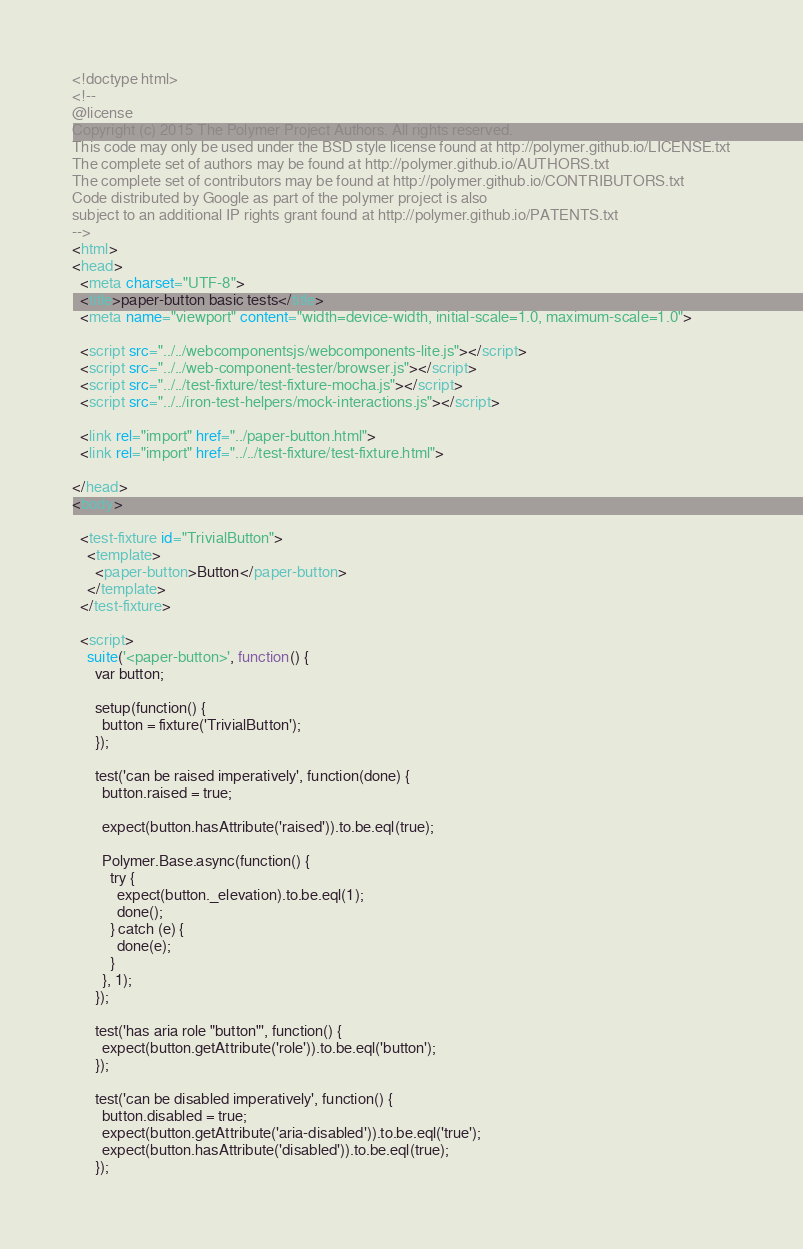Convert code to text. <code><loc_0><loc_0><loc_500><loc_500><_HTML_><!doctype html>
<!--
@license
Copyright (c) 2015 The Polymer Project Authors. All rights reserved.
This code may only be used under the BSD style license found at http://polymer.github.io/LICENSE.txt
The complete set of authors may be found at http://polymer.github.io/AUTHORS.txt
The complete set of contributors may be found at http://polymer.github.io/CONTRIBUTORS.txt
Code distributed by Google as part of the polymer project is also
subject to an additional IP rights grant found at http://polymer.github.io/PATENTS.txt
-->
<html>
<head>
  <meta charset="UTF-8">
  <title>paper-button basic tests</title>
  <meta name="viewport" content="width=device-width, initial-scale=1.0, maximum-scale=1.0">

  <script src="../../webcomponentsjs/webcomponents-lite.js"></script>
  <script src="../../web-component-tester/browser.js"></script>
  <script src="../../test-fixture/test-fixture-mocha.js"></script>
  <script src="../../iron-test-helpers/mock-interactions.js"></script>

  <link rel="import" href="../paper-button.html">
  <link rel="import" href="../../test-fixture/test-fixture.html">

</head>
<body>

  <test-fixture id="TrivialButton">
    <template>
      <paper-button>Button</paper-button>
    </template>
  </test-fixture>

  <script>
    suite('<paper-button>', function() {
      var button;

      setup(function() {
        button = fixture('TrivialButton');
      });

      test('can be raised imperatively', function(done) {
        button.raised = true;

        expect(button.hasAttribute('raised')).to.be.eql(true);

        Polymer.Base.async(function() {
          try {
            expect(button._elevation).to.be.eql(1);
            done();
          } catch (e) {
            done(e);
          }
        }, 1);
      });

      test('has aria role "button"', function() {
        expect(button.getAttribute('role')).to.be.eql('button');
      });

      test('can be disabled imperatively', function() {
        button.disabled = true;
        expect(button.getAttribute('aria-disabled')).to.be.eql('true');
        expect(button.hasAttribute('disabled')).to.be.eql(true);
      });
</code> 